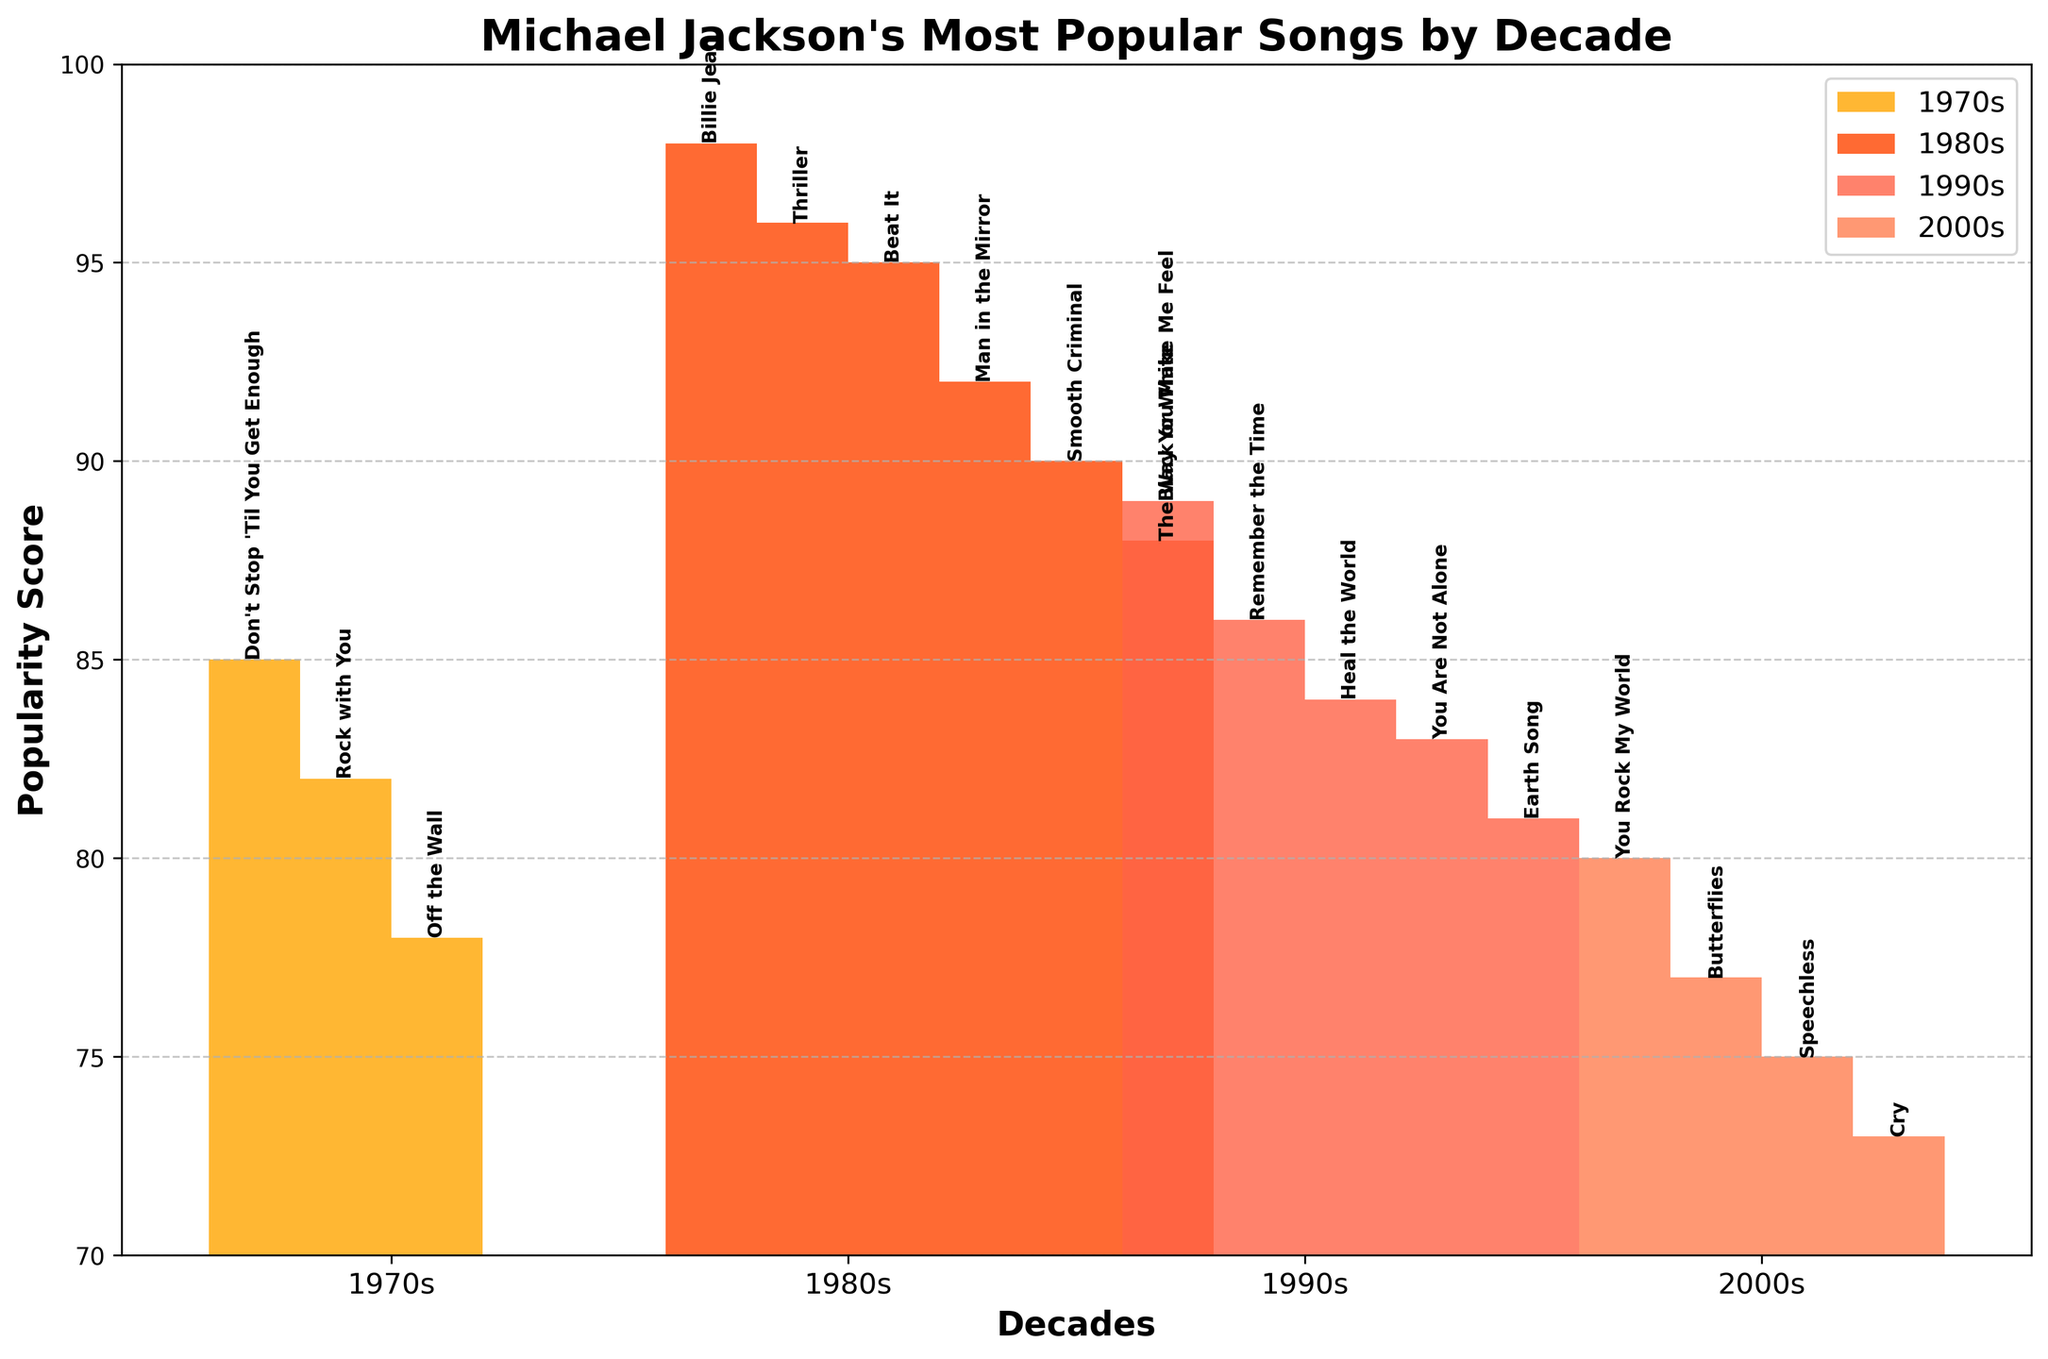Which decade has the highest average popularity score? The average popularity score for each decade can be calculated by summing up the popularity scores of the songs in each decade and then dividing by the number of songs in that decade. For the 1970s: (85 + 82 + 78) / 3 ≈ 81.67; 1980s: (98 + 96 + 95 + 92 + 90 + 88) / 6 ≈ 93.17; 1990s: (89 + 86 + 84 + 83 + 81) / 5 = 84.6; 2000s: (80 + 77 + 75 + 73) / 4 = 76.25. The 1980s has the highest average popularity score.
Answer: 1980s Which song in the 1980s has the highest popularity score? By examining the height of the bars for the 1980s, we see that "Billie Jean" has the tallest bar with a popularity score of 98.
Answer: Billie Jean What is the total popularity score for the 1990s? The total popularity score can be calculated by summing all the popularity scores for the 1990s. That's 89 + 86 + 84 + 83 + 81 = 423.
Answer: 423 Which decade has the lowest number of popular songs listed in the chart? Count the number of bars for each decade. The 1970s have 3, the 1980s have 6, the 1990s have 5, and the 2000s have 4. The 1970s have the lowest number of popular songs listed.
Answer: 1970s Which decade features the song "Off the Wall" and what is its popularity score? Locate the song "Off the Wall" and read the decade label and its associated popularity score, which is in the 1970s with a score of 78.
Answer: 1970s, 78 Considering only the 2000s, what is the difference in popularity scores between the most popular and least popular songs? In the 2000s, the highest popularity score is 80 ("You Rock My World") and the lowest is 73 ("Cry"). The difference is 80 - 73 = 7.
Answer: 7 Comparing the songs "Thriller" and "Smooth Criminal," which one is more popular and by how much? "Thriller" has a popularity score of 96 and "Smooth Criminal" has a score of 90. "Thriller" is more popular by 96 - 90 = 6.
Answer: Thriller, 6 What is the average popularity score of the songs in the 2000s? The average popularity score for the 2000s can be calculated by summing the scores (80 + 77 + 75 + 73) and dividing by the number of songs (4). The sum is 305, so the average is 305 / 4 = 76.25.
Answer: 76.25 